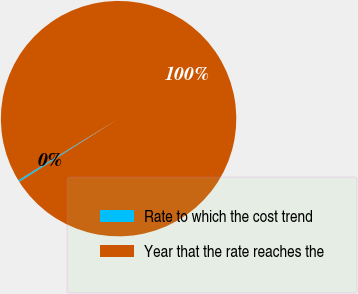Convert chart. <chart><loc_0><loc_0><loc_500><loc_500><pie_chart><fcel>Rate to which the cost trend<fcel>Year that the rate reaches the<nl><fcel>0.25%<fcel>99.75%<nl></chart> 